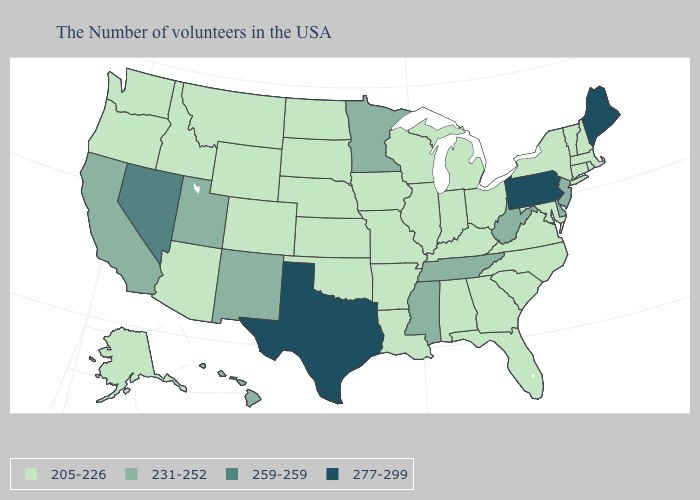Name the states that have a value in the range 205-226?
Be succinct. Massachusetts, Rhode Island, New Hampshire, Vermont, Connecticut, New York, Maryland, Virginia, North Carolina, South Carolina, Ohio, Florida, Georgia, Michigan, Kentucky, Indiana, Alabama, Wisconsin, Illinois, Louisiana, Missouri, Arkansas, Iowa, Kansas, Nebraska, Oklahoma, South Dakota, North Dakota, Wyoming, Colorado, Montana, Arizona, Idaho, Washington, Oregon, Alaska. Does Idaho have the lowest value in the USA?
Answer briefly. Yes. What is the value of Georgia?
Give a very brief answer. 205-226. What is the highest value in the MidWest ?
Answer briefly. 231-252. Name the states that have a value in the range 231-252?
Keep it brief. New Jersey, Delaware, West Virginia, Tennessee, Mississippi, Minnesota, New Mexico, Utah, California, Hawaii. Which states have the highest value in the USA?
Short answer required. Maine, Pennsylvania, Texas. Name the states that have a value in the range 231-252?
Quick response, please. New Jersey, Delaware, West Virginia, Tennessee, Mississippi, Minnesota, New Mexico, Utah, California, Hawaii. Does the map have missing data?
Short answer required. No. What is the lowest value in the USA?
Answer briefly. 205-226. What is the lowest value in the West?
Keep it brief. 205-226. Name the states that have a value in the range 205-226?
Concise answer only. Massachusetts, Rhode Island, New Hampshire, Vermont, Connecticut, New York, Maryland, Virginia, North Carolina, South Carolina, Ohio, Florida, Georgia, Michigan, Kentucky, Indiana, Alabama, Wisconsin, Illinois, Louisiana, Missouri, Arkansas, Iowa, Kansas, Nebraska, Oklahoma, South Dakota, North Dakota, Wyoming, Colorado, Montana, Arizona, Idaho, Washington, Oregon, Alaska. What is the highest value in states that border Montana?
Answer briefly. 205-226. Which states have the highest value in the USA?
Give a very brief answer. Maine, Pennsylvania, Texas. 